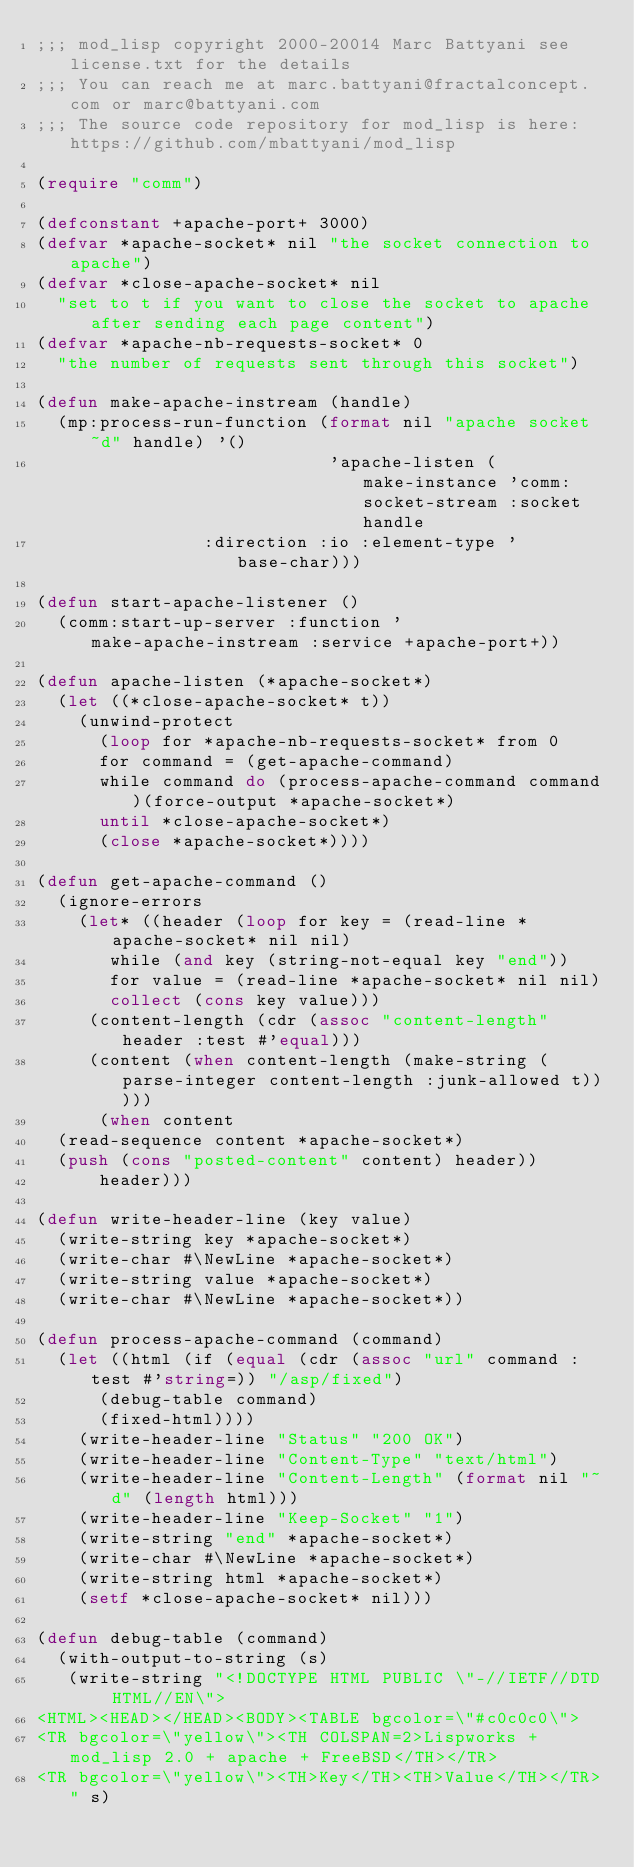Convert code to text. <code><loc_0><loc_0><loc_500><loc_500><_Lisp_>;;; mod_lisp copyright 2000-20014 Marc Battyani see license.txt for the details
;;; You can reach me at marc.battyani@fractalconcept.com or marc@battyani.com
;;; The source code repository for mod_lisp is here: https://github.com/mbattyani/mod_lisp

(require "comm")

(defconstant +apache-port+ 3000)
(defvar *apache-socket* nil "the socket connection to apache")
(defvar *close-apache-socket* nil
  "set to t if you want to close the socket to apache after sending each page content")
(defvar *apache-nb-requests-socket* 0
  "the number of requests sent through this socket")

(defun make-apache-instream (handle)
  (mp:process-run-function (format nil "apache socket ~d" handle) '()
                            'apache-listen (make-instance 'comm:socket-stream :socket handle
							  :direction :io :element-type 'base-char)))

(defun start-apache-listener ()
  (comm:start-up-server :function 'make-apache-instream :service +apache-port+))

(defun apache-listen (*apache-socket*)
  (let ((*close-apache-socket* t))
    (unwind-protect
      (loop for *apache-nb-requests-socket* from 0
	    for command = (get-apache-command)
	    while command do (process-apache-command command)(force-output *apache-socket*)
	    until *close-apache-socket*)
      (close *apache-socket*))))

(defun get-apache-command ()
  (ignore-errors
    (let* ((header (loop for key = (read-line *apache-socket* nil nil)
			 while (and key (string-not-equal key "end"))
			 for value = (read-line *apache-socket* nil nil)
			 collect (cons key value)))
	   (content-length (cdr (assoc "content-length" header :test #'equal)))
	   (content (when content-length (make-string (parse-integer content-length :junk-allowed t)))))
      (when content
	(read-sequence content *apache-socket*)
	(push (cons "posted-content" content) header))
      header)))

(defun write-header-line (key value)
  (write-string key *apache-socket*)
  (write-char #\NewLine *apache-socket*)
  (write-string value *apache-socket*)
  (write-char #\NewLine *apache-socket*))

(defun process-apache-command (command)
  (let ((html (if (equal (cdr (assoc "url" command :test #'string=)) "/asp/fixed")
		  (debug-table command)
		  (fixed-html))))
    (write-header-line "Status" "200 OK")
    (write-header-line "Content-Type" "text/html")
    (write-header-line "Content-Length" (format nil "~d" (length html)))
    (write-header-line "Keep-Socket" "1")
    (write-string "end" *apache-socket*)
    (write-char #\NewLine *apache-socket*)
    (write-string html *apache-socket*)
    (setf *close-apache-socket* nil)))

(defun debug-table (command)
  (with-output-to-string (s)
   (write-string "<!DOCTYPE HTML PUBLIC \"-//IETF//DTD HTML//EN\">
<HTML><HEAD></HEAD><BODY><TABLE bgcolor=\"#c0c0c0\">
<TR bgcolor=\"yellow\"><TH COLSPAN=2>Lispworks + mod_lisp 2.0 + apache + FreeBSD</TH></TR>
<TR bgcolor=\"yellow\"><TH>Key</TH><TH>Value</TH></TR>" s)</code> 